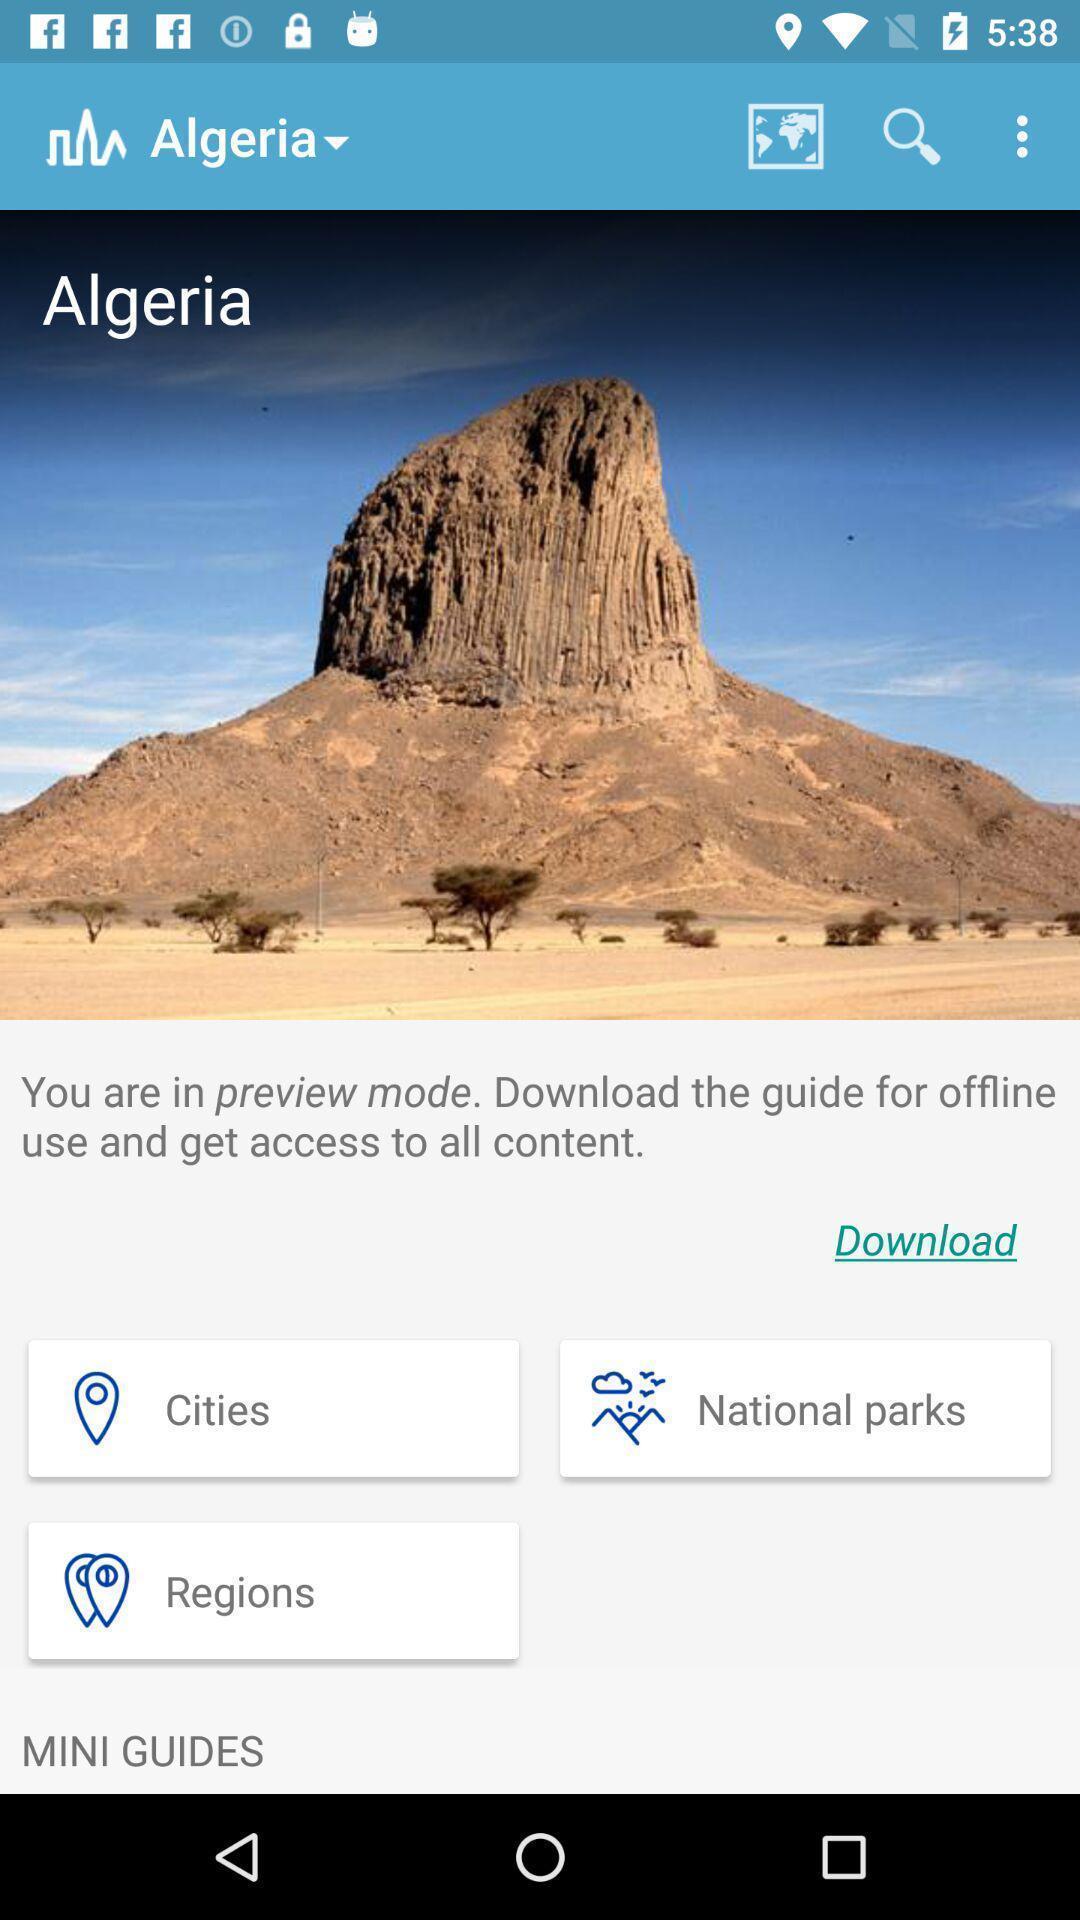Give me a summary of this screen capture. Page displaying search option for address. 